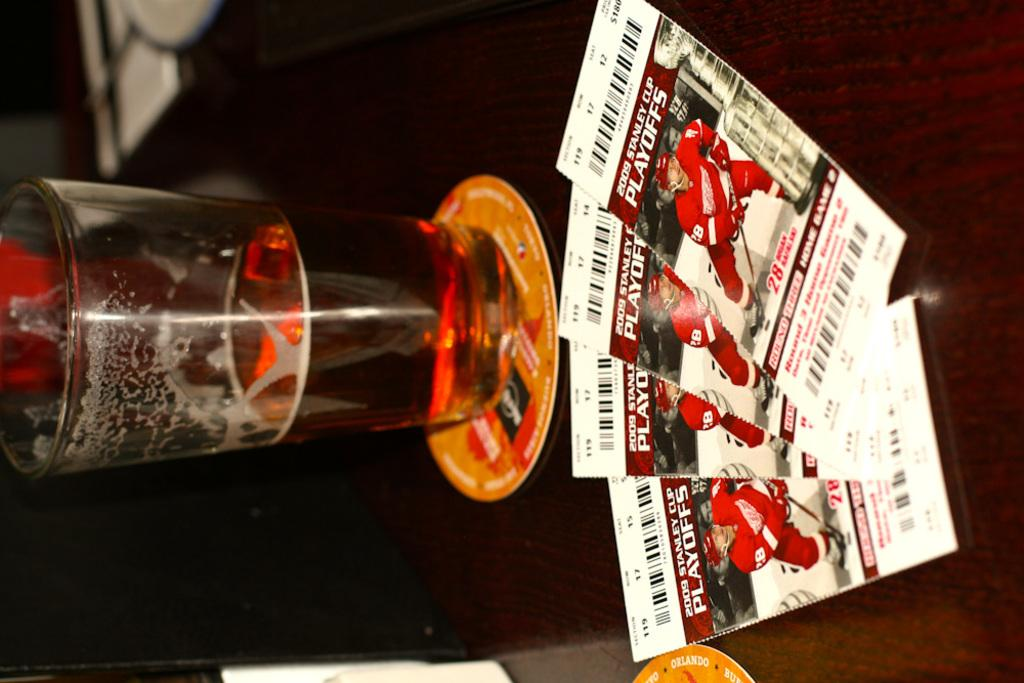What is located in the center of the image? There is a table in the center of the image. What can be seen on the table? There is a glass and papers on the table. What type of poison is visible in the glass on the table? There is no poison visible in the glass on the table; it is a glass containing an unspecified liquid or substance. Is there a cactus present on the table in the image? There is no cactus present on the table in the image. 